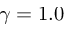Convert formula to latex. <formula><loc_0><loc_0><loc_500><loc_500>\gamma = 1 . 0</formula> 